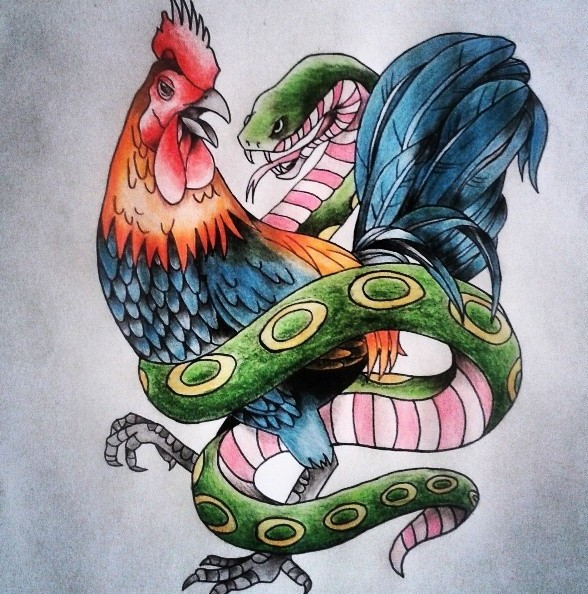What might the vibrant colors of the rooster and snake bring to mind in this context? The vibrant colors of the rooster and snake add layers of meaning to the illustration. The rooster's bright plumage can symbolize vitality, bravery, and the life force, while the snake's vivid greens and patterns could represent the mystery and allure of the unknown. These colors make the dynamic interplay between the two animals more striking, possibly emphasizing themes of attraction and repulsion, or the beauty inherent in conflict. 